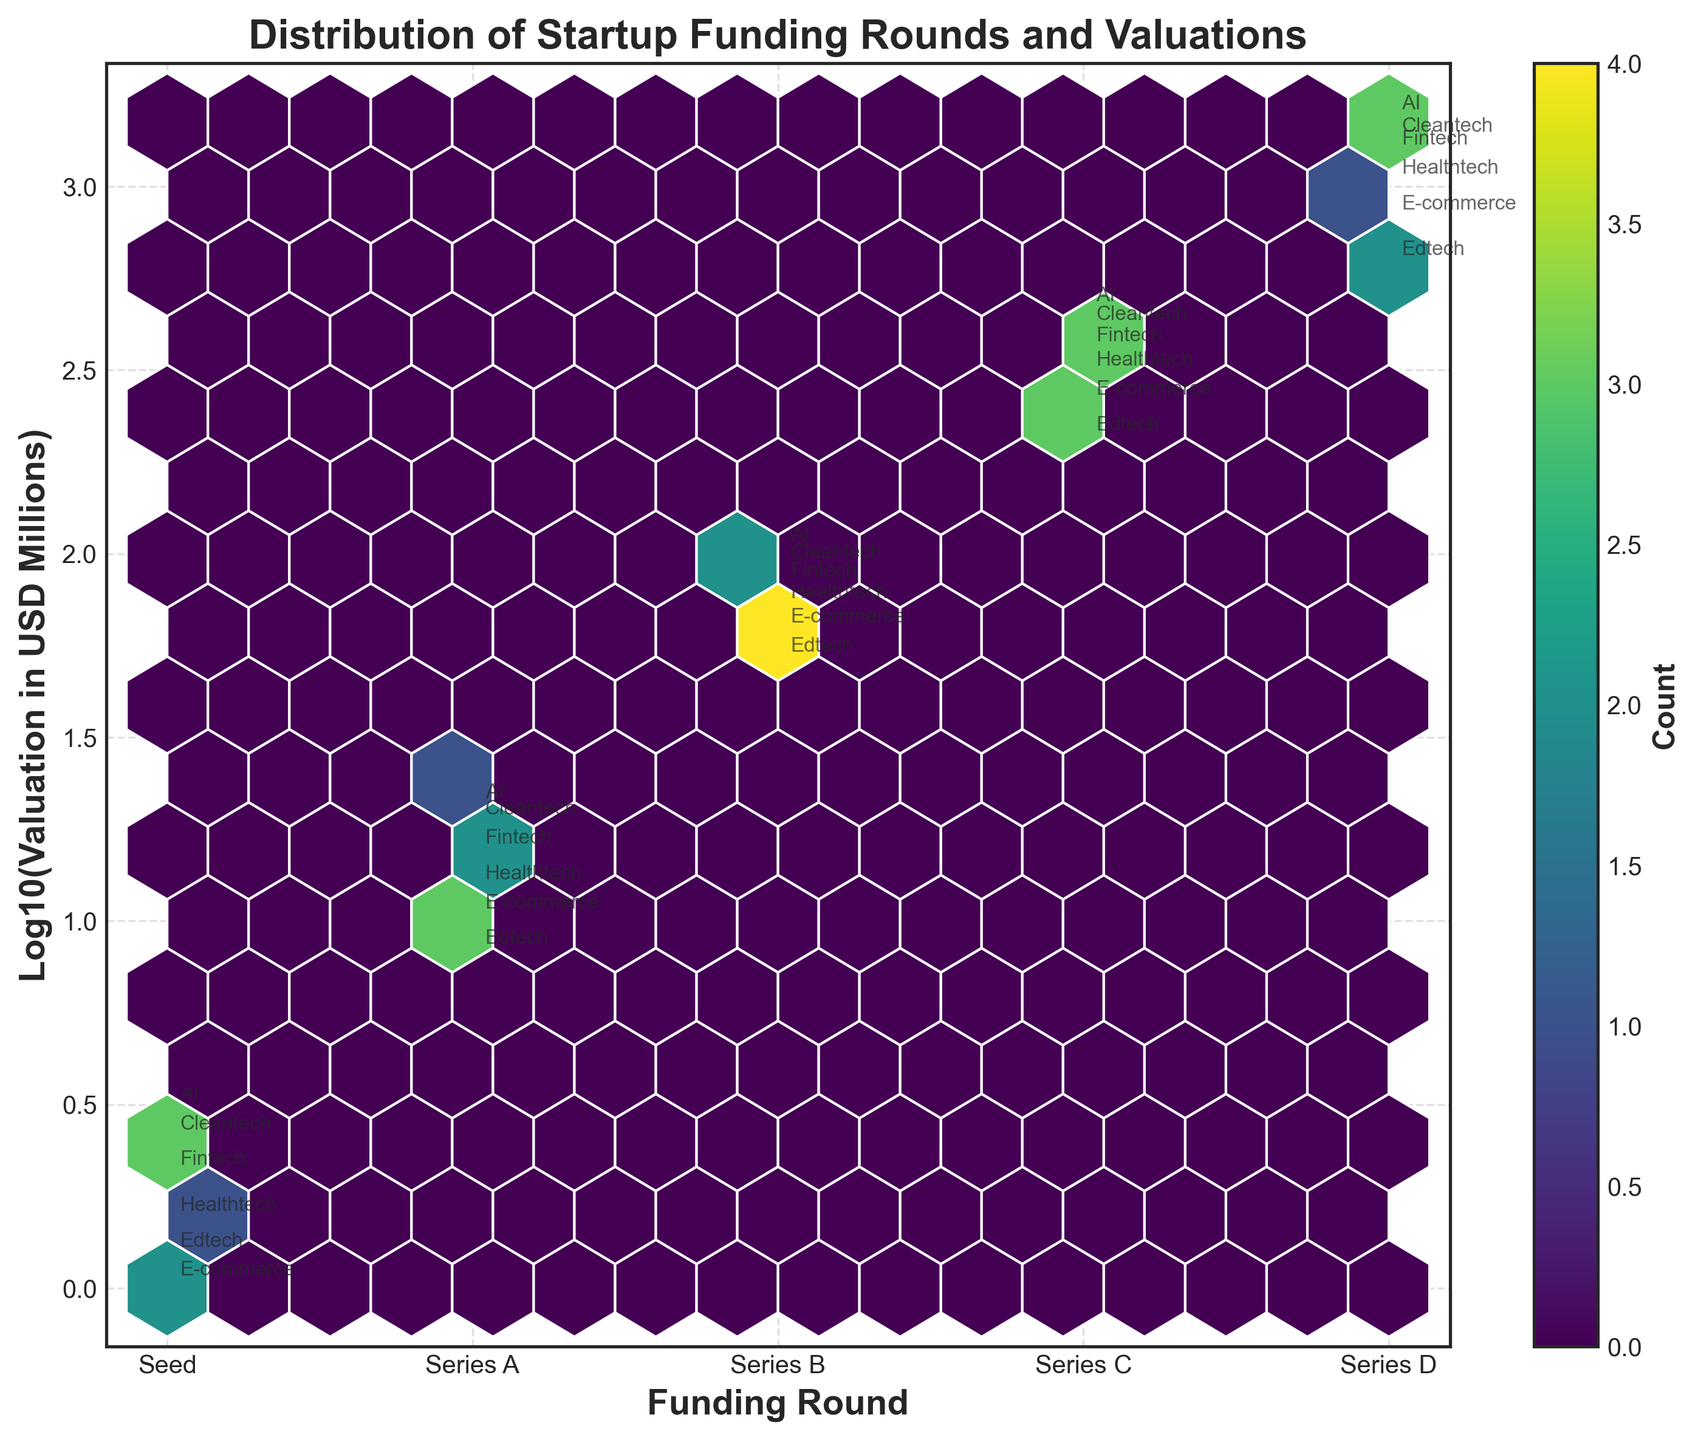what is the title of the plot? The title of the plot is text displayed prominently at the top of the figure. It gives a quick summary of what the visual represents.
Answer: Distribution of Startup Funding Rounds and Valuations How many funding rounds are presented on the x-axis? The x-axis labels display the different categories of funding rounds. By counting these labels, we can determine the number of categories.
Answer: 5 What does the color intensity represent? In a hexbin plot, different shades of the hexagons usually represent the density or count of data points within that bin. The color bar typically labels what the colors mean.
Answer: Count of data points Which funding round shows the highest concentration of valuations? To answer this, look for the funding round with the darkest or most numerous hexagons, indicating the highest density of data points.
Answer: Series B Which sector has the highest valuation in Series D? Locate Series D on the x-axis, then find the highest point on the y-axis within that column. The annotation near that point will indicate the sector.
Answer: AI How does the average valuation change from Seed to Series D funding round? To determine this, examine the y-axis values (log-transformed) across each funding round from Seed to Series D. Note the general trend or pattern in the valuations.
Answer: Increases Which funding round shows the lowest valuations among all sectors? Look on the x-axis for the funding round and find the lowest points on the y-axis. This represents the lowest log-transformed valuations.
Answer: Seed Are there more data points in Series A or Series C funding round? Look at the densities and number of hexagons filled for Series A and Series C. More and darker hexagons indicate a greater number of data points.
Answer: Series A How does the Healthtech sector's valuation in Series B compare to Fintech in Series B? Locate both 'Healthtech' and 'Fintech' annotations in the Series B column on the x-axis, then compare their positions on the y-axis to see which is higher.
Answer: Healthtech is lower than Fintech 